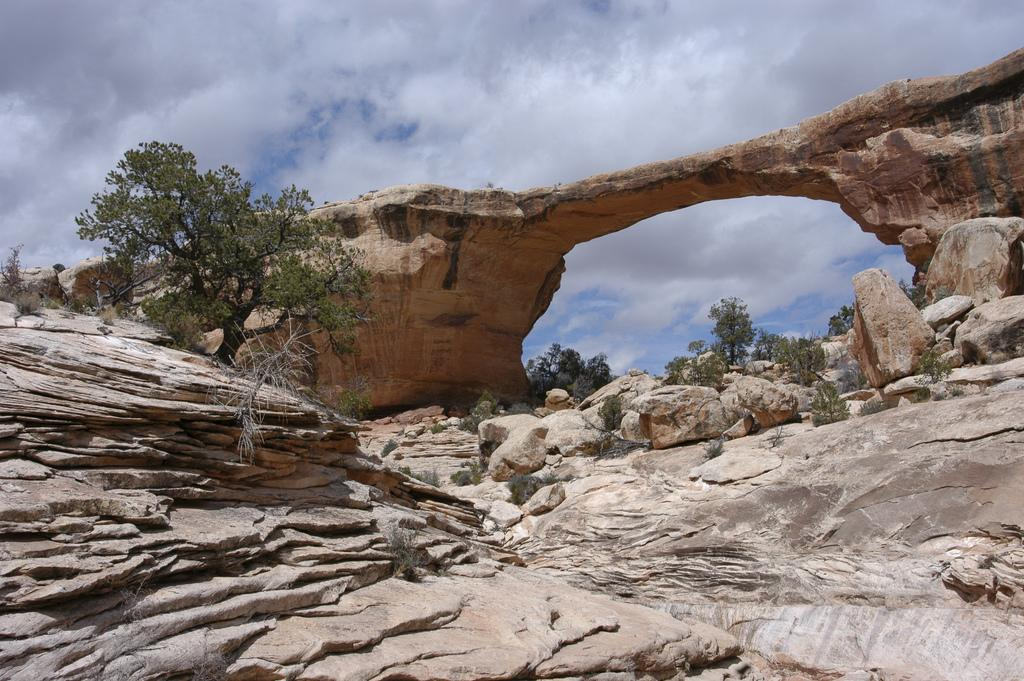What is the main subject of the image? The image features the Owachomo Bridge. What other natural elements can be seen in the image? There are rocks, trees, and plants visible in the image. What is the condition of the sky in the image? Clouds are present in the sky. Can you tell me how many goldfish are swimming in the river under the bridge in the image? There are no goldfish visible in the image; it features the Owachomo Bridge, rocks, trees, plants, and clouds. What type of pest can be seen crawling on the bridge in the image? There are no pests visible in the image; it features the Owachomo Bridge, rocks, trees, plants, and clouds. 